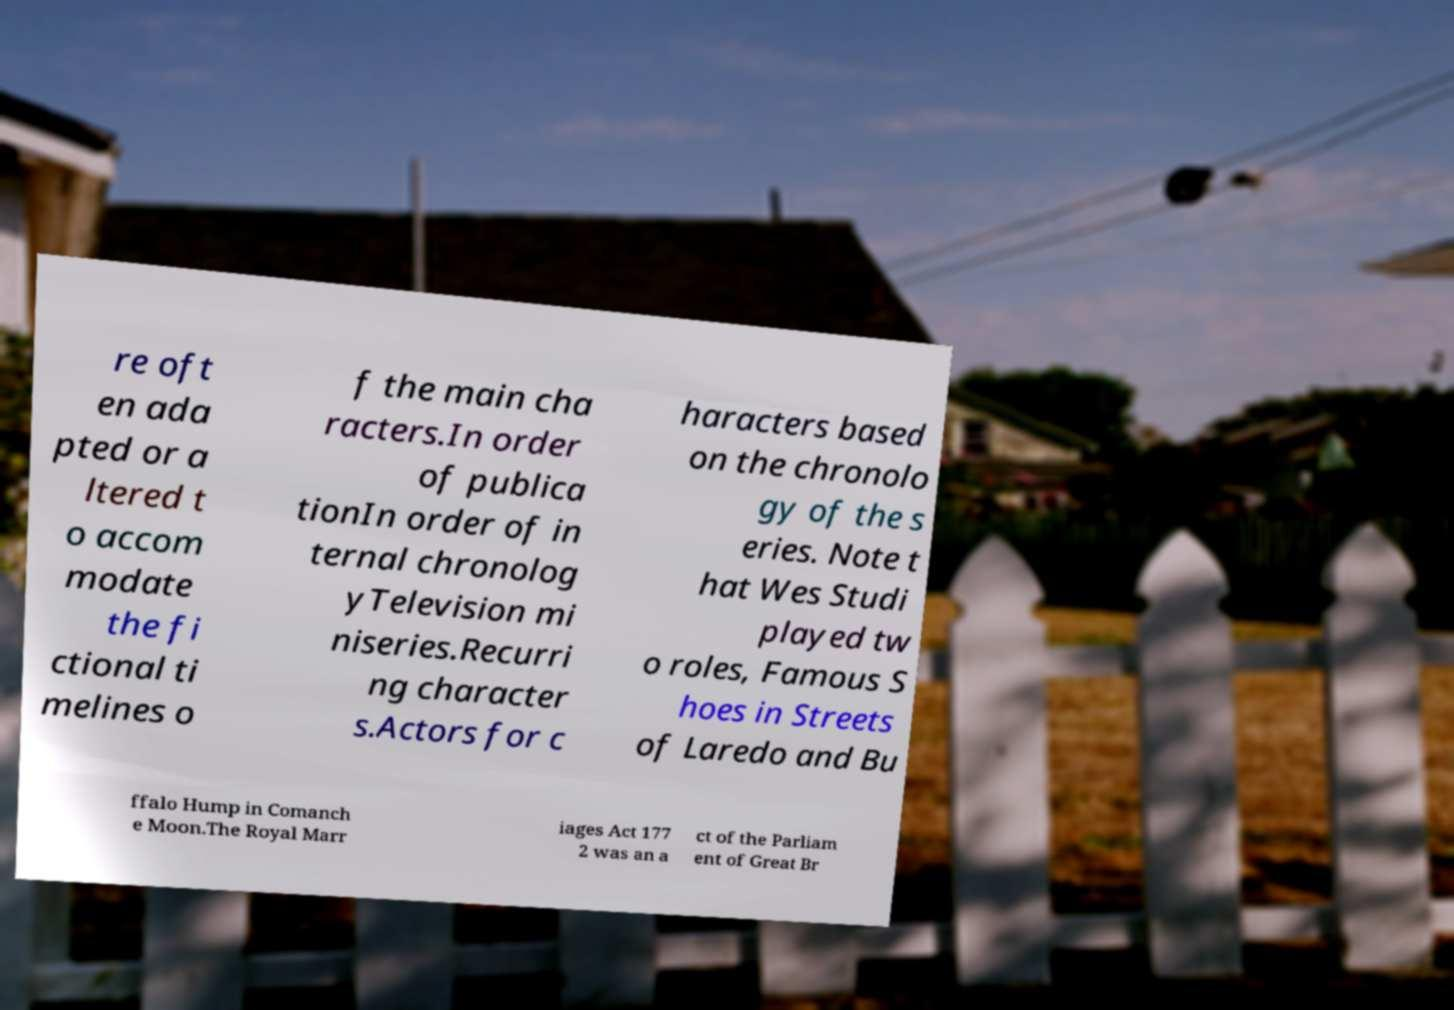Can you read and provide the text displayed in the image?This photo seems to have some interesting text. Can you extract and type it out for me? re oft en ada pted or a ltered t o accom modate the fi ctional ti melines o f the main cha racters.In order of publica tionIn order of in ternal chronolog yTelevision mi niseries.Recurri ng character s.Actors for c haracters based on the chronolo gy of the s eries. Note t hat Wes Studi played tw o roles, Famous S hoes in Streets of Laredo and Bu ffalo Hump in Comanch e Moon.The Royal Marr iages Act 177 2 was an a ct of the Parliam ent of Great Br 